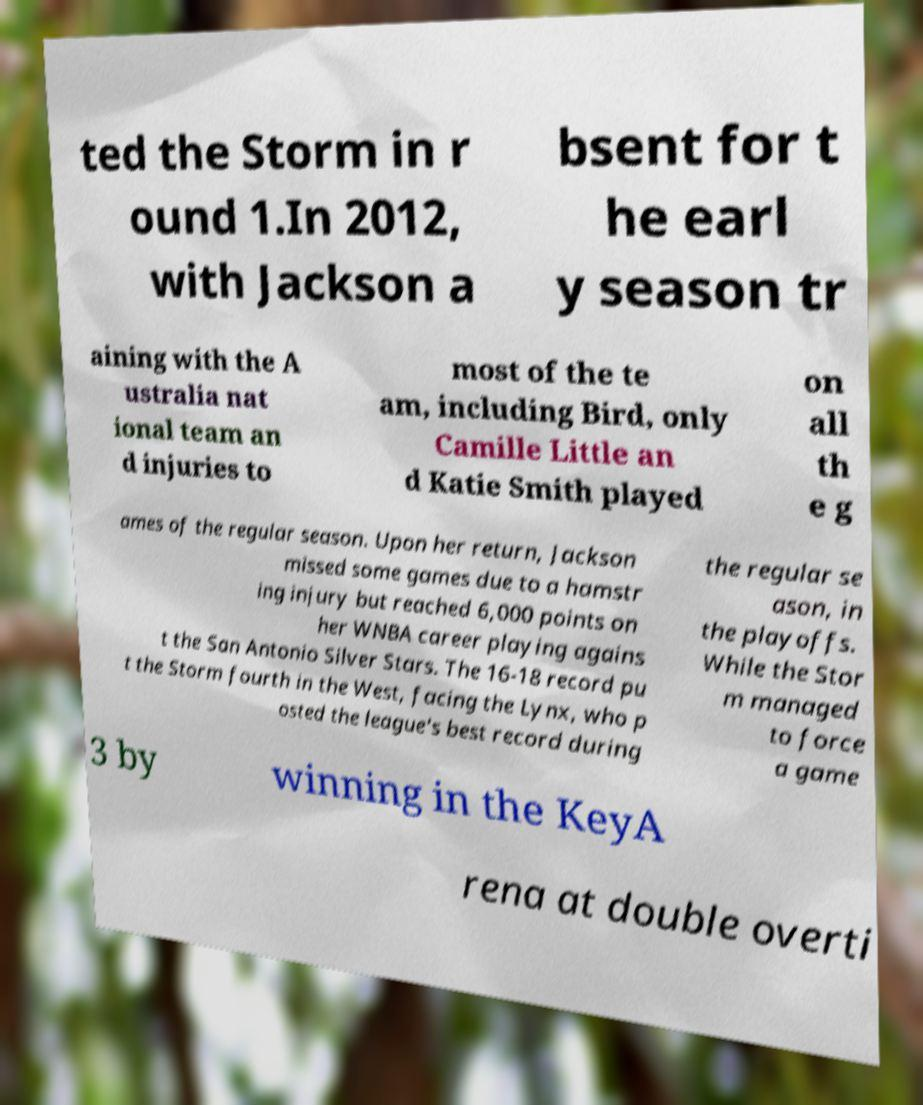Can you read and provide the text displayed in the image?This photo seems to have some interesting text. Can you extract and type it out for me? ted the Storm in r ound 1.In 2012, with Jackson a bsent for t he earl y season tr aining with the A ustralia nat ional team an d injuries to most of the te am, including Bird, only Camille Little an d Katie Smith played on all th e g ames of the regular season. Upon her return, Jackson missed some games due to a hamstr ing injury but reached 6,000 points on her WNBA career playing agains t the San Antonio Silver Stars. The 16-18 record pu t the Storm fourth in the West, facing the Lynx, who p osted the league's best record during the regular se ason, in the playoffs. While the Stor m managed to force a game 3 by winning in the KeyA rena at double overti 